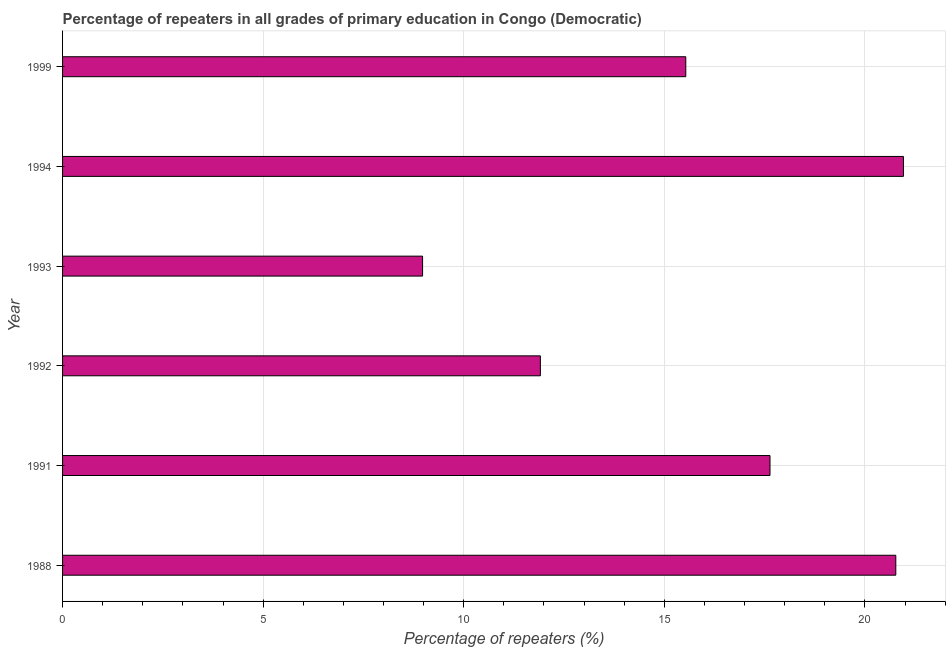Does the graph contain any zero values?
Keep it short and to the point. No. Does the graph contain grids?
Offer a terse response. Yes. What is the title of the graph?
Your answer should be very brief. Percentage of repeaters in all grades of primary education in Congo (Democratic). What is the label or title of the X-axis?
Offer a very short reply. Percentage of repeaters (%). What is the label or title of the Y-axis?
Give a very brief answer. Year. What is the percentage of repeaters in primary education in 1994?
Provide a short and direct response. 20.96. Across all years, what is the maximum percentage of repeaters in primary education?
Keep it short and to the point. 20.96. Across all years, what is the minimum percentage of repeaters in primary education?
Offer a terse response. 8.97. In which year was the percentage of repeaters in primary education maximum?
Provide a short and direct response. 1994. In which year was the percentage of repeaters in primary education minimum?
Offer a terse response. 1993. What is the sum of the percentage of repeaters in primary education?
Make the answer very short. 95.78. What is the difference between the percentage of repeaters in primary education in 1992 and 1999?
Provide a succinct answer. -3.62. What is the average percentage of repeaters in primary education per year?
Keep it short and to the point. 15.96. What is the median percentage of repeaters in primary education?
Provide a succinct answer. 16.58. Is the percentage of repeaters in primary education in 1991 less than that in 1999?
Provide a short and direct response. No. Is the difference between the percentage of repeaters in primary education in 1992 and 1999 greater than the difference between any two years?
Keep it short and to the point. No. What is the difference between the highest and the second highest percentage of repeaters in primary education?
Offer a very short reply. 0.19. What is the difference between the highest and the lowest percentage of repeaters in primary education?
Your answer should be compact. 11.99. In how many years, is the percentage of repeaters in primary education greater than the average percentage of repeaters in primary education taken over all years?
Your response must be concise. 3. How many bars are there?
Keep it short and to the point. 6. Are all the bars in the graph horizontal?
Make the answer very short. Yes. Are the values on the major ticks of X-axis written in scientific E-notation?
Your answer should be compact. No. What is the Percentage of repeaters (%) of 1988?
Your answer should be very brief. 20.77. What is the Percentage of repeaters (%) in 1991?
Give a very brief answer. 17.63. What is the Percentage of repeaters (%) of 1992?
Your answer should be very brief. 11.91. What is the Percentage of repeaters (%) in 1993?
Give a very brief answer. 8.97. What is the Percentage of repeaters (%) in 1994?
Your answer should be compact. 20.96. What is the Percentage of repeaters (%) of 1999?
Keep it short and to the point. 15.53. What is the difference between the Percentage of repeaters (%) in 1988 and 1991?
Ensure brevity in your answer.  3.14. What is the difference between the Percentage of repeaters (%) in 1988 and 1992?
Make the answer very short. 8.86. What is the difference between the Percentage of repeaters (%) in 1988 and 1993?
Your answer should be very brief. 11.8. What is the difference between the Percentage of repeaters (%) in 1988 and 1994?
Ensure brevity in your answer.  -0.19. What is the difference between the Percentage of repeaters (%) in 1988 and 1999?
Keep it short and to the point. 5.23. What is the difference between the Percentage of repeaters (%) in 1991 and 1992?
Your answer should be compact. 5.72. What is the difference between the Percentage of repeaters (%) in 1991 and 1993?
Make the answer very short. 8.66. What is the difference between the Percentage of repeaters (%) in 1991 and 1994?
Ensure brevity in your answer.  -3.33. What is the difference between the Percentage of repeaters (%) in 1991 and 1999?
Keep it short and to the point. 2.1. What is the difference between the Percentage of repeaters (%) in 1992 and 1993?
Your response must be concise. 2.94. What is the difference between the Percentage of repeaters (%) in 1992 and 1994?
Provide a succinct answer. -9.05. What is the difference between the Percentage of repeaters (%) in 1992 and 1999?
Offer a terse response. -3.62. What is the difference between the Percentage of repeaters (%) in 1993 and 1994?
Make the answer very short. -11.99. What is the difference between the Percentage of repeaters (%) in 1993 and 1999?
Ensure brevity in your answer.  -6.56. What is the difference between the Percentage of repeaters (%) in 1994 and 1999?
Keep it short and to the point. 5.43. What is the ratio of the Percentage of repeaters (%) in 1988 to that in 1991?
Offer a terse response. 1.18. What is the ratio of the Percentage of repeaters (%) in 1988 to that in 1992?
Ensure brevity in your answer.  1.74. What is the ratio of the Percentage of repeaters (%) in 1988 to that in 1993?
Your response must be concise. 2.31. What is the ratio of the Percentage of repeaters (%) in 1988 to that in 1999?
Offer a very short reply. 1.34. What is the ratio of the Percentage of repeaters (%) in 1991 to that in 1992?
Provide a succinct answer. 1.48. What is the ratio of the Percentage of repeaters (%) in 1991 to that in 1993?
Keep it short and to the point. 1.97. What is the ratio of the Percentage of repeaters (%) in 1991 to that in 1994?
Your answer should be very brief. 0.84. What is the ratio of the Percentage of repeaters (%) in 1991 to that in 1999?
Keep it short and to the point. 1.14. What is the ratio of the Percentage of repeaters (%) in 1992 to that in 1993?
Provide a succinct answer. 1.33. What is the ratio of the Percentage of repeaters (%) in 1992 to that in 1994?
Offer a very short reply. 0.57. What is the ratio of the Percentage of repeaters (%) in 1992 to that in 1999?
Give a very brief answer. 0.77. What is the ratio of the Percentage of repeaters (%) in 1993 to that in 1994?
Give a very brief answer. 0.43. What is the ratio of the Percentage of repeaters (%) in 1993 to that in 1999?
Ensure brevity in your answer.  0.58. What is the ratio of the Percentage of repeaters (%) in 1994 to that in 1999?
Your answer should be very brief. 1.35. 